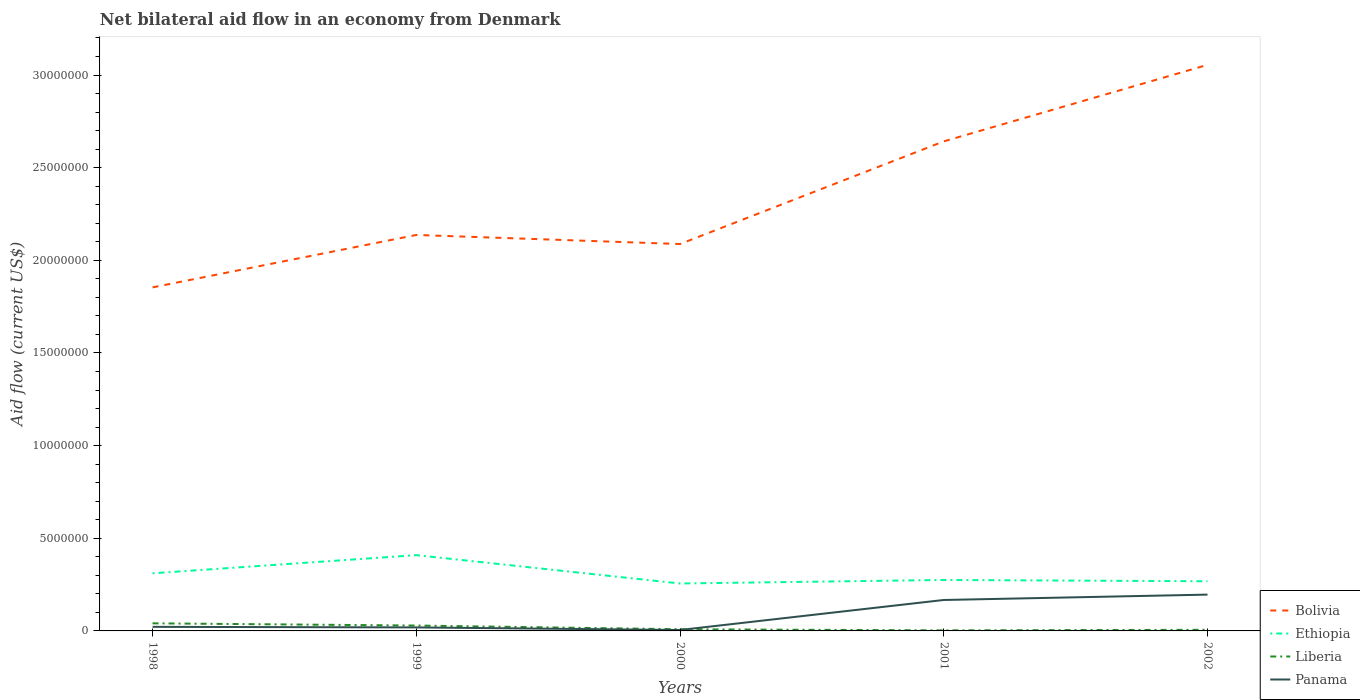Does the line corresponding to Liberia intersect with the line corresponding to Panama?
Provide a succinct answer. Yes. What is the total net bilateral aid flow in Liberia in the graph?
Keep it short and to the point. 3.50e+05. What is the difference between the highest and the second highest net bilateral aid flow in Liberia?
Your response must be concise. 3.80e+05. What is the difference between the highest and the lowest net bilateral aid flow in Panama?
Ensure brevity in your answer.  2. Are the values on the major ticks of Y-axis written in scientific E-notation?
Give a very brief answer. No. Does the graph contain any zero values?
Your answer should be very brief. No. Does the graph contain grids?
Give a very brief answer. No. Where does the legend appear in the graph?
Give a very brief answer. Bottom right. How are the legend labels stacked?
Provide a short and direct response. Vertical. What is the title of the graph?
Make the answer very short. Net bilateral aid flow in an economy from Denmark. Does "Uzbekistan" appear as one of the legend labels in the graph?
Make the answer very short. No. What is the Aid flow (current US$) in Bolivia in 1998?
Provide a succinct answer. 1.85e+07. What is the Aid flow (current US$) of Ethiopia in 1998?
Offer a terse response. 3.11e+06. What is the Aid flow (current US$) of Bolivia in 1999?
Provide a short and direct response. 2.14e+07. What is the Aid flow (current US$) of Ethiopia in 1999?
Make the answer very short. 4.09e+06. What is the Aid flow (current US$) of Panama in 1999?
Give a very brief answer. 1.90e+05. What is the Aid flow (current US$) of Bolivia in 2000?
Offer a very short reply. 2.09e+07. What is the Aid flow (current US$) of Ethiopia in 2000?
Provide a short and direct response. 2.56e+06. What is the Aid flow (current US$) of Bolivia in 2001?
Ensure brevity in your answer.  2.64e+07. What is the Aid flow (current US$) in Ethiopia in 2001?
Give a very brief answer. 2.75e+06. What is the Aid flow (current US$) of Panama in 2001?
Offer a terse response. 1.67e+06. What is the Aid flow (current US$) of Bolivia in 2002?
Offer a terse response. 3.06e+07. What is the Aid flow (current US$) of Ethiopia in 2002?
Make the answer very short. 2.68e+06. What is the Aid flow (current US$) in Panama in 2002?
Ensure brevity in your answer.  1.96e+06. Across all years, what is the maximum Aid flow (current US$) of Bolivia?
Your response must be concise. 3.06e+07. Across all years, what is the maximum Aid flow (current US$) of Ethiopia?
Keep it short and to the point. 4.09e+06. Across all years, what is the maximum Aid flow (current US$) in Liberia?
Offer a very short reply. 4.10e+05. Across all years, what is the maximum Aid flow (current US$) of Panama?
Provide a short and direct response. 1.96e+06. Across all years, what is the minimum Aid flow (current US$) in Bolivia?
Your answer should be compact. 1.85e+07. Across all years, what is the minimum Aid flow (current US$) of Ethiopia?
Make the answer very short. 2.56e+06. Across all years, what is the minimum Aid flow (current US$) of Liberia?
Offer a very short reply. 3.00e+04. Across all years, what is the minimum Aid flow (current US$) of Panama?
Keep it short and to the point. 5.00e+04. What is the total Aid flow (current US$) of Bolivia in the graph?
Your answer should be very brief. 1.18e+08. What is the total Aid flow (current US$) of Ethiopia in the graph?
Your answer should be very brief. 1.52e+07. What is the total Aid flow (current US$) in Liberia in the graph?
Your answer should be compact. 8.80e+05. What is the total Aid flow (current US$) in Panama in the graph?
Your answer should be compact. 4.09e+06. What is the difference between the Aid flow (current US$) in Bolivia in 1998 and that in 1999?
Your answer should be compact. -2.83e+06. What is the difference between the Aid flow (current US$) of Ethiopia in 1998 and that in 1999?
Your answer should be compact. -9.80e+05. What is the difference between the Aid flow (current US$) in Bolivia in 1998 and that in 2000?
Your response must be concise. -2.34e+06. What is the difference between the Aid flow (current US$) of Ethiopia in 1998 and that in 2000?
Your answer should be compact. 5.50e+05. What is the difference between the Aid flow (current US$) in Liberia in 1998 and that in 2000?
Your response must be concise. 3.20e+05. What is the difference between the Aid flow (current US$) in Panama in 1998 and that in 2000?
Offer a very short reply. 1.70e+05. What is the difference between the Aid flow (current US$) in Bolivia in 1998 and that in 2001?
Keep it short and to the point. -7.88e+06. What is the difference between the Aid flow (current US$) in Panama in 1998 and that in 2001?
Give a very brief answer. -1.45e+06. What is the difference between the Aid flow (current US$) of Bolivia in 1998 and that in 2002?
Give a very brief answer. -1.20e+07. What is the difference between the Aid flow (current US$) of Ethiopia in 1998 and that in 2002?
Your response must be concise. 4.30e+05. What is the difference between the Aid flow (current US$) in Panama in 1998 and that in 2002?
Offer a very short reply. -1.74e+06. What is the difference between the Aid flow (current US$) of Ethiopia in 1999 and that in 2000?
Provide a short and direct response. 1.53e+06. What is the difference between the Aid flow (current US$) of Liberia in 1999 and that in 2000?
Keep it short and to the point. 2.00e+05. What is the difference between the Aid flow (current US$) of Panama in 1999 and that in 2000?
Keep it short and to the point. 1.40e+05. What is the difference between the Aid flow (current US$) of Bolivia in 1999 and that in 2001?
Give a very brief answer. -5.05e+06. What is the difference between the Aid flow (current US$) in Ethiopia in 1999 and that in 2001?
Keep it short and to the point. 1.34e+06. What is the difference between the Aid flow (current US$) in Liberia in 1999 and that in 2001?
Your response must be concise. 2.60e+05. What is the difference between the Aid flow (current US$) of Panama in 1999 and that in 2001?
Keep it short and to the point. -1.48e+06. What is the difference between the Aid flow (current US$) of Bolivia in 1999 and that in 2002?
Offer a very short reply. -9.18e+06. What is the difference between the Aid flow (current US$) of Ethiopia in 1999 and that in 2002?
Your answer should be very brief. 1.41e+06. What is the difference between the Aid flow (current US$) in Liberia in 1999 and that in 2002?
Offer a very short reply. 2.30e+05. What is the difference between the Aid flow (current US$) of Panama in 1999 and that in 2002?
Your answer should be compact. -1.77e+06. What is the difference between the Aid flow (current US$) in Bolivia in 2000 and that in 2001?
Offer a very short reply. -5.54e+06. What is the difference between the Aid flow (current US$) in Panama in 2000 and that in 2001?
Provide a short and direct response. -1.62e+06. What is the difference between the Aid flow (current US$) of Bolivia in 2000 and that in 2002?
Provide a succinct answer. -9.67e+06. What is the difference between the Aid flow (current US$) in Ethiopia in 2000 and that in 2002?
Make the answer very short. -1.20e+05. What is the difference between the Aid flow (current US$) of Liberia in 2000 and that in 2002?
Offer a terse response. 3.00e+04. What is the difference between the Aid flow (current US$) of Panama in 2000 and that in 2002?
Provide a succinct answer. -1.91e+06. What is the difference between the Aid flow (current US$) in Bolivia in 2001 and that in 2002?
Ensure brevity in your answer.  -4.13e+06. What is the difference between the Aid flow (current US$) in Bolivia in 1998 and the Aid flow (current US$) in Ethiopia in 1999?
Provide a succinct answer. 1.44e+07. What is the difference between the Aid flow (current US$) of Bolivia in 1998 and the Aid flow (current US$) of Liberia in 1999?
Ensure brevity in your answer.  1.82e+07. What is the difference between the Aid flow (current US$) of Bolivia in 1998 and the Aid flow (current US$) of Panama in 1999?
Your answer should be compact. 1.84e+07. What is the difference between the Aid flow (current US$) in Ethiopia in 1998 and the Aid flow (current US$) in Liberia in 1999?
Keep it short and to the point. 2.82e+06. What is the difference between the Aid flow (current US$) in Ethiopia in 1998 and the Aid flow (current US$) in Panama in 1999?
Give a very brief answer. 2.92e+06. What is the difference between the Aid flow (current US$) of Liberia in 1998 and the Aid flow (current US$) of Panama in 1999?
Provide a short and direct response. 2.20e+05. What is the difference between the Aid flow (current US$) of Bolivia in 1998 and the Aid flow (current US$) of Ethiopia in 2000?
Provide a succinct answer. 1.60e+07. What is the difference between the Aid flow (current US$) of Bolivia in 1998 and the Aid flow (current US$) of Liberia in 2000?
Give a very brief answer. 1.84e+07. What is the difference between the Aid flow (current US$) of Bolivia in 1998 and the Aid flow (current US$) of Panama in 2000?
Offer a very short reply. 1.85e+07. What is the difference between the Aid flow (current US$) of Ethiopia in 1998 and the Aid flow (current US$) of Liberia in 2000?
Give a very brief answer. 3.02e+06. What is the difference between the Aid flow (current US$) of Ethiopia in 1998 and the Aid flow (current US$) of Panama in 2000?
Offer a very short reply. 3.06e+06. What is the difference between the Aid flow (current US$) in Bolivia in 1998 and the Aid flow (current US$) in Ethiopia in 2001?
Your response must be concise. 1.58e+07. What is the difference between the Aid flow (current US$) of Bolivia in 1998 and the Aid flow (current US$) of Liberia in 2001?
Make the answer very short. 1.85e+07. What is the difference between the Aid flow (current US$) in Bolivia in 1998 and the Aid flow (current US$) in Panama in 2001?
Offer a terse response. 1.69e+07. What is the difference between the Aid flow (current US$) in Ethiopia in 1998 and the Aid flow (current US$) in Liberia in 2001?
Your answer should be compact. 3.08e+06. What is the difference between the Aid flow (current US$) of Ethiopia in 1998 and the Aid flow (current US$) of Panama in 2001?
Your answer should be compact. 1.44e+06. What is the difference between the Aid flow (current US$) of Liberia in 1998 and the Aid flow (current US$) of Panama in 2001?
Keep it short and to the point. -1.26e+06. What is the difference between the Aid flow (current US$) in Bolivia in 1998 and the Aid flow (current US$) in Ethiopia in 2002?
Make the answer very short. 1.59e+07. What is the difference between the Aid flow (current US$) in Bolivia in 1998 and the Aid flow (current US$) in Liberia in 2002?
Offer a terse response. 1.85e+07. What is the difference between the Aid flow (current US$) of Bolivia in 1998 and the Aid flow (current US$) of Panama in 2002?
Ensure brevity in your answer.  1.66e+07. What is the difference between the Aid flow (current US$) in Ethiopia in 1998 and the Aid flow (current US$) in Liberia in 2002?
Your answer should be very brief. 3.05e+06. What is the difference between the Aid flow (current US$) in Ethiopia in 1998 and the Aid flow (current US$) in Panama in 2002?
Your answer should be compact. 1.15e+06. What is the difference between the Aid flow (current US$) in Liberia in 1998 and the Aid flow (current US$) in Panama in 2002?
Your response must be concise. -1.55e+06. What is the difference between the Aid flow (current US$) of Bolivia in 1999 and the Aid flow (current US$) of Ethiopia in 2000?
Make the answer very short. 1.88e+07. What is the difference between the Aid flow (current US$) of Bolivia in 1999 and the Aid flow (current US$) of Liberia in 2000?
Keep it short and to the point. 2.13e+07. What is the difference between the Aid flow (current US$) of Bolivia in 1999 and the Aid flow (current US$) of Panama in 2000?
Ensure brevity in your answer.  2.13e+07. What is the difference between the Aid flow (current US$) in Ethiopia in 1999 and the Aid flow (current US$) in Liberia in 2000?
Your answer should be compact. 4.00e+06. What is the difference between the Aid flow (current US$) in Ethiopia in 1999 and the Aid flow (current US$) in Panama in 2000?
Ensure brevity in your answer.  4.04e+06. What is the difference between the Aid flow (current US$) of Bolivia in 1999 and the Aid flow (current US$) of Ethiopia in 2001?
Your answer should be compact. 1.86e+07. What is the difference between the Aid flow (current US$) in Bolivia in 1999 and the Aid flow (current US$) in Liberia in 2001?
Ensure brevity in your answer.  2.13e+07. What is the difference between the Aid flow (current US$) of Bolivia in 1999 and the Aid flow (current US$) of Panama in 2001?
Keep it short and to the point. 1.97e+07. What is the difference between the Aid flow (current US$) of Ethiopia in 1999 and the Aid flow (current US$) of Liberia in 2001?
Ensure brevity in your answer.  4.06e+06. What is the difference between the Aid flow (current US$) in Ethiopia in 1999 and the Aid flow (current US$) in Panama in 2001?
Your response must be concise. 2.42e+06. What is the difference between the Aid flow (current US$) in Liberia in 1999 and the Aid flow (current US$) in Panama in 2001?
Give a very brief answer. -1.38e+06. What is the difference between the Aid flow (current US$) in Bolivia in 1999 and the Aid flow (current US$) in Ethiopia in 2002?
Make the answer very short. 1.87e+07. What is the difference between the Aid flow (current US$) of Bolivia in 1999 and the Aid flow (current US$) of Liberia in 2002?
Provide a succinct answer. 2.13e+07. What is the difference between the Aid flow (current US$) of Bolivia in 1999 and the Aid flow (current US$) of Panama in 2002?
Your response must be concise. 1.94e+07. What is the difference between the Aid flow (current US$) in Ethiopia in 1999 and the Aid flow (current US$) in Liberia in 2002?
Offer a very short reply. 4.03e+06. What is the difference between the Aid flow (current US$) of Ethiopia in 1999 and the Aid flow (current US$) of Panama in 2002?
Your answer should be compact. 2.13e+06. What is the difference between the Aid flow (current US$) in Liberia in 1999 and the Aid flow (current US$) in Panama in 2002?
Make the answer very short. -1.67e+06. What is the difference between the Aid flow (current US$) of Bolivia in 2000 and the Aid flow (current US$) of Ethiopia in 2001?
Offer a terse response. 1.81e+07. What is the difference between the Aid flow (current US$) in Bolivia in 2000 and the Aid flow (current US$) in Liberia in 2001?
Give a very brief answer. 2.08e+07. What is the difference between the Aid flow (current US$) of Bolivia in 2000 and the Aid flow (current US$) of Panama in 2001?
Offer a very short reply. 1.92e+07. What is the difference between the Aid flow (current US$) of Ethiopia in 2000 and the Aid flow (current US$) of Liberia in 2001?
Offer a very short reply. 2.53e+06. What is the difference between the Aid flow (current US$) in Ethiopia in 2000 and the Aid flow (current US$) in Panama in 2001?
Ensure brevity in your answer.  8.90e+05. What is the difference between the Aid flow (current US$) in Liberia in 2000 and the Aid flow (current US$) in Panama in 2001?
Provide a short and direct response. -1.58e+06. What is the difference between the Aid flow (current US$) of Bolivia in 2000 and the Aid flow (current US$) of Ethiopia in 2002?
Your response must be concise. 1.82e+07. What is the difference between the Aid flow (current US$) in Bolivia in 2000 and the Aid flow (current US$) in Liberia in 2002?
Provide a succinct answer. 2.08e+07. What is the difference between the Aid flow (current US$) in Bolivia in 2000 and the Aid flow (current US$) in Panama in 2002?
Your response must be concise. 1.89e+07. What is the difference between the Aid flow (current US$) of Ethiopia in 2000 and the Aid flow (current US$) of Liberia in 2002?
Ensure brevity in your answer.  2.50e+06. What is the difference between the Aid flow (current US$) in Liberia in 2000 and the Aid flow (current US$) in Panama in 2002?
Ensure brevity in your answer.  -1.87e+06. What is the difference between the Aid flow (current US$) in Bolivia in 2001 and the Aid flow (current US$) in Ethiopia in 2002?
Provide a succinct answer. 2.37e+07. What is the difference between the Aid flow (current US$) in Bolivia in 2001 and the Aid flow (current US$) in Liberia in 2002?
Provide a short and direct response. 2.64e+07. What is the difference between the Aid flow (current US$) of Bolivia in 2001 and the Aid flow (current US$) of Panama in 2002?
Give a very brief answer. 2.45e+07. What is the difference between the Aid flow (current US$) of Ethiopia in 2001 and the Aid flow (current US$) of Liberia in 2002?
Ensure brevity in your answer.  2.69e+06. What is the difference between the Aid flow (current US$) of Ethiopia in 2001 and the Aid flow (current US$) of Panama in 2002?
Your answer should be very brief. 7.90e+05. What is the difference between the Aid flow (current US$) in Liberia in 2001 and the Aid flow (current US$) in Panama in 2002?
Provide a succinct answer. -1.93e+06. What is the average Aid flow (current US$) in Bolivia per year?
Keep it short and to the point. 2.36e+07. What is the average Aid flow (current US$) in Ethiopia per year?
Provide a succinct answer. 3.04e+06. What is the average Aid flow (current US$) in Liberia per year?
Your answer should be compact. 1.76e+05. What is the average Aid flow (current US$) in Panama per year?
Keep it short and to the point. 8.18e+05. In the year 1998, what is the difference between the Aid flow (current US$) in Bolivia and Aid flow (current US$) in Ethiopia?
Your response must be concise. 1.54e+07. In the year 1998, what is the difference between the Aid flow (current US$) in Bolivia and Aid flow (current US$) in Liberia?
Your response must be concise. 1.81e+07. In the year 1998, what is the difference between the Aid flow (current US$) of Bolivia and Aid flow (current US$) of Panama?
Offer a very short reply. 1.83e+07. In the year 1998, what is the difference between the Aid flow (current US$) in Ethiopia and Aid flow (current US$) in Liberia?
Give a very brief answer. 2.70e+06. In the year 1998, what is the difference between the Aid flow (current US$) of Ethiopia and Aid flow (current US$) of Panama?
Keep it short and to the point. 2.89e+06. In the year 1999, what is the difference between the Aid flow (current US$) in Bolivia and Aid flow (current US$) in Ethiopia?
Give a very brief answer. 1.73e+07. In the year 1999, what is the difference between the Aid flow (current US$) of Bolivia and Aid flow (current US$) of Liberia?
Your answer should be compact. 2.11e+07. In the year 1999, what is the difference between the Aid flow (current US$) in Bolivia and Aid flow (current US$) in Panama?
Your response must be concise. 2.12e+07. In the year 1999, what is the difference between the Aid flow (current US$) in Ethiopia and Aid flow (current US$) in Liberia?
Your answer should be very brief. 3.80e+06. In the year 1999, what is the difference between the Aid flow (current US$) of Ethiopia and Aid flow (current US$) of Panama?
Give a very brief answer. 3.90e+06. In the year 2000, what is the difference between the Aid flow (current US$) in Bolivia and Aid flow (current US$) in Ethiopia?
Make the answer very short. 1.83e+07. In the year 2000, what is the difference between the Aid flow (current US$) of Bolivia and Aid flow (current US$) of Liberia?
Provide a short and direct response. 2.08e+07. In the year 2000, what is the difference between the Aid flow (current US$) in Bolivia and Aid flow (current US$) in Panama?
Your answer should be very brief. 2.08e+07. In the year 2000, what is the difference between the Aid flow (current US$) in Ethiopia and Aid flow (current US$) in Liberia?
Your answer should be very brief. 2.47e+06. In the year 2000, what is the difference between the Aid flow (current US$) of Ethiopia and Aid flow (current US$) of Panama?
Provide a short and direct response. 2.51e+06. In the year 2000, what is the difference between the Aid flow (current US$) in Liberia and Aid flow (current US$) in Panama?
Ensure brevity in your answer.  4.00e+04. In the year 2001, what is the difference between the Aid flow (current US$) in Bolivia and Aid flow (current US$) in Ethiopia?
Provide a succinct answer. 2.37e+07. In the year 2001, what is the difference between the Aid flow (current US$) of Bolivia and Aid flow (current US$) of Liberia?
Give a very brief answer. 2.64e+07. In the year 2001, what is the difference between the Aid flow (current US$) of Bolivia and Aid flow (current US$) of Panama?
Your answer should be compact. 2.48e+07. In the year 2001, what is the difference between the Aid flow (current US$) in Ethiopia and Aid flow (current US$) in Liberia?
Your response must be concise. 2.72e+06. In the year 2001, what is the difference between the Aid flow (current US$) of Ethiopia and Aid flow (current US$) of Panama?
Your response must be concise. 1.08e+06. In the year 2001, what is the difference between the Aid flow (current US$) in Liberia and Aid flow (current US$) in Panama?
Ensure brevity in your answer.  -1.64e+06. In the year 2002, what is the difference between the Aid flow (current US$) of Bolivia and Aid flow (current US$) of Ethiopia?
Keep it short and to the point. 2.79e+07. In the year 2002, what is the difference between the Aid flow (current US$) of Bolivia and Aid flow (current US$) of Liberia?
Your answer should be compact. 3.05e+07. In the year 2002, what is the difference between the Aid flow (current US$) of Bolivia and Aid flow (current US$) of Panama?
Offer a terse response. 2.86e+07. In the year 2002, what is the difference between the Aid flow (current US$) in Ethiopia and Aid flow (current US$) in Liberia?
Provide a succinct answer. 2.62e+06. In the year 2002, what is the difference between the Aid flow (current US$) of Ethiopia and Aid flow (current US$) of Panama?
Keep it short and to the point. 7.20e+05. In the year 2002, what is the difference between the Aid flow (current US$) of Liberia and Aid flow (current US$) of Panama?
Give a very brief answer. -1.90e+06. What is the ratio of the Aid flow (current US$) in Bolivia in 1998 to that in 1999?
Your answer should be compact. 0.87. What is the ratio of the Aid flow (current US$) of Ethiopia in 1998 to that in 1999?
Ensure brevity in your answer.  0.76. What is the ratio of the Aid flow (current US$) in Liberia in 1998 to that in 1999?
Give a very brief answer. 1.41. What is the ratio of the Aid flow (current US$) of Panama in 1998 to that in 1999?
Give a very brief answer. 1.16. What is the ratio of the Aid flow (current US$) of Bolivia in 1998 to that in 2000?
Your answer should be compact. 0.89. What is the ratio of the Aid flow (current US$) in Ethiopia in 1998 to that in 2000?
Provide a succinct answer. 1.21. What is the ratio of the Aid flow (current US$) of Liberia in 1998 to that in 2000?
Keep it short and to the point. 4.56. What is the ratio of the Aid flow (current US$) of Bolivia in 1998 to that in 2001?
Keep it short and to the point. 0.7. What is the ratio of the Aid flow (current US$) of Ethiopia in 1998 to that in 2001?
Offer a terse response. 1.13. What is the ratio of the Aid flow (current US$) of Liberia in 1998 to that in 2001?
Make the answer very short. 13.67. What is the ratio of the Aid flow (current US$) in Panama in 1998 to that in 2001?
Make the answer very short. 0.13. What is the ratio of the Aid flow (current US$) of Bolivia in 1998 to that in 2002?
Your answer should be very brief. 0.61. What is the ratio of the Aid flow (current US$) of Ethiopia in 1998 to that in 2002?
Your answer should be very brief. 1.16. What is the ratio of the Aid flow (current US$) in Liberia in 1998 to that in 2002?
Provide a short and direct response. 6.83. What is the ratio of the Aid flow (current US$) of Panama in 1998 to that in 2002?
Your answer should be very brief. 0.11. What is the ratio of the Aid flow (current US$) of Bolivia in 1999 to that in 2000?
Your answer should be compact. 1.02. What is the ratio of the Aid flow (current US$) in Ethiopia in 1999 to that in 2000?
Offer a very short reply. 1.6. What is the ratio of the Aid flow (current US$) in Liberia in 1999 to that in 2000?
Your answer should be compact. 3.22. What is the ratio of the Aid flow (current US$) of Panama in 1999 to that in 2000?
Your response must be concise. 3.8. What is the ratio of the Aid flow (current US$) of Bolivia in 1999 to that in 2001?
Your answer should be compact. 0.81. What is the ratio of the Aid flow (current US$) in Ethiopia in 1999 to that in 2001?
Keep it short and to the point. 1.49. What is the ratio of the Aid flow (current US$) in Liberia in 1999 to that in 2001?
Your answer should be very brief. 9.67. What is the ratio of the Aid flow (current US$) of Panama in 1999 to that in 2001?
Your response must be concise. 0.11. What is the ratio of the Aid flow (current US$) of Bolivia in 1999 to that in 2002?
Give a very brief answer. 0.7. What is the ratio of the Aid flow (current US$) in Ethiopia in 1999 to that in 2002?
Your response must be concise. 1.53. What is the ratio of the Aid flow (current US$) of Liberia in 1999 to that in 2002?
Give a very brief answer. 4.83. What is the ratio of the Aid flow (current US$) in Panama in 1999 to that in 2002?
Your answer should be compact. 0.1. What is the ratio of the Aid flow (current US$) in Bolivia in 2000 to that in 2001?
Make the answer very short. 0.79. What is the ratio of the Aid flow (current US$) in Ethiopia in 2000 to that in 2001?
Give a very brief answer. 0.93. What is the ratio of the Aid flow (current US$) of Panama in 2000 to that in 2001?
Your response must be concise. 0.03. What is the ratio of the Aid flow (current US$) in Bolivia in 2000 to that in 2002?
Provide a succinct answer. 0.68. What is the ratio of the Aid flow (current US$) in Ethiopia in 2000 to that in 2002?
Your answer should be very brief. 0.96. What is the ratio of the Aid flow (current US$) of Liberia in 2000 to that in 2002?
Give a very brief answer. 1.5. What is the ratio of the Aid flow (current US$) in Panama in 2000 to that in 2002?
Your response must be concise. 0.03. What is the ratio of the Aid flow (current US$) of Bolivia in 2001 to that in 2002?
Keep it short and to the point. 0.86. What is the ratio of the Aid flow (current US$) of Ethiopia in 2001 to that in 2002?
Provide a succinct answer. 1.03. What is the ratio of the Aid flow (current US$) in Liberia in 2001 to that in 2002?
Keep it short and to the point. 0.5. What is the ratio of the Aid flow (current US$) in Panama in 2001 to that in 2002?
Provide a short and direct response. 0.85. What is the difference between the highest and the second highest Aid flow (current US$) in Bolivia?
Provide a succinct answer. 4.13e+06. What is the difference between the highest and the second highest Aid flow (current US$) of Ethiopia?
Ensure brevity in your answer.  9.80e+05. What is the difference between the highest and the second highest Aid flow (current US$) in Liberia?
Your answer should be very brief. 1.20e+05. What is the difference between the highest and the lowest Aid flow (current US$) of Bolivia?
Offer a terse response. 1.20e+07. What is the difference between the highest and the lowest Aid flow (current US$) of Ethiopia?
Keep it short and to the point. 1.53e+06. What is the difference between the highest and the lowest Aid flow (current US$) in Panama?
Ensure brevity in your answer.  1.91e+06. 